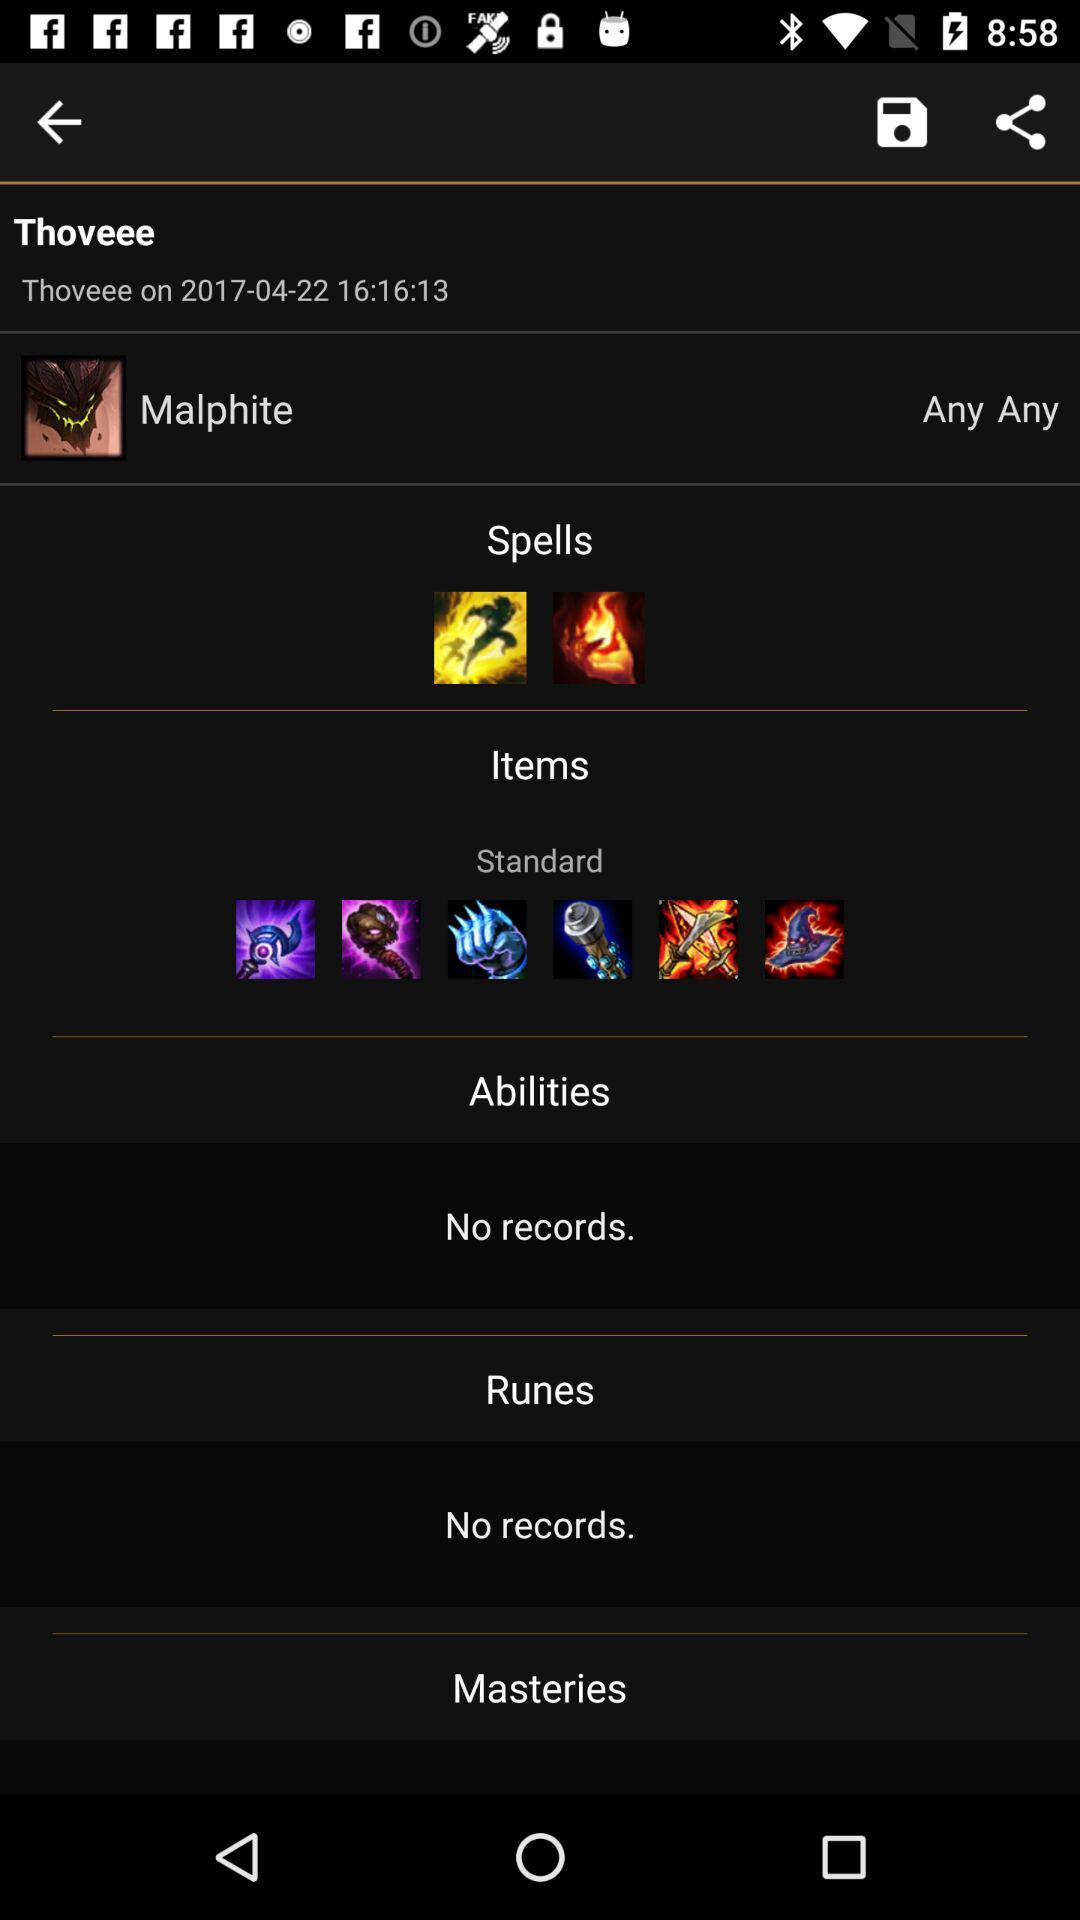What is the date of "Thoveee"? The date is April 22, 2017. 